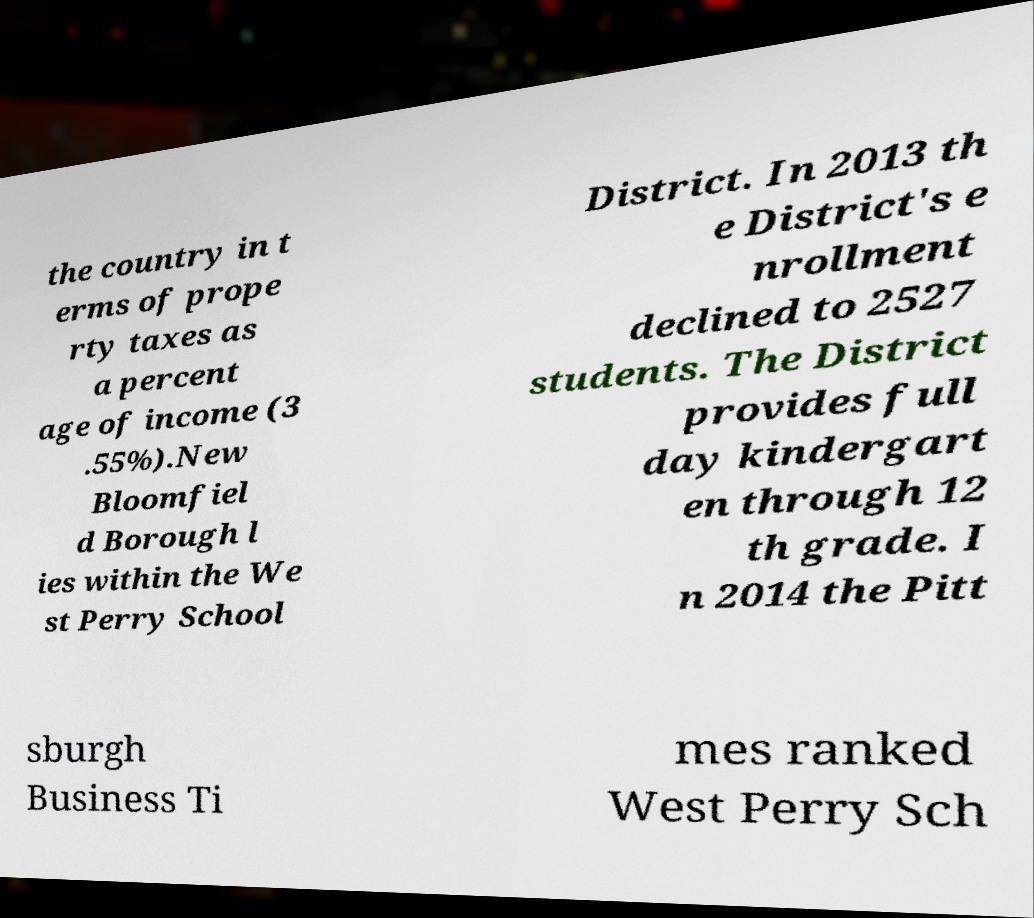For documentation purposes, I need the text within this image transcribed. Could you provide that? the country in t erms of prope rty taxes as a percent age of income (3 .55%).New Bloomfiel d Borough l ies within the We st Perry School District. In 2013 th e District's e nrollment declined to 2527 students. The District provides full day kindergart en through 12 th grade. I n 2014 the Pitt sburgh Business Ti mes ranked West Perry Sch 